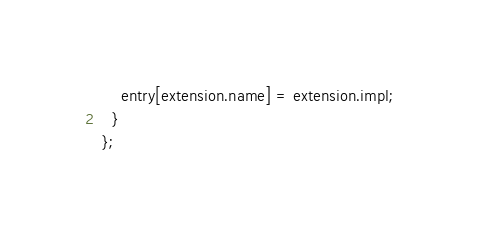Convert code to text. <code><loc_0><loc_0><loc_500><loc_500><_JavaScript_>    entry[extension.name] = extension.impl;
  }
};
</code> 